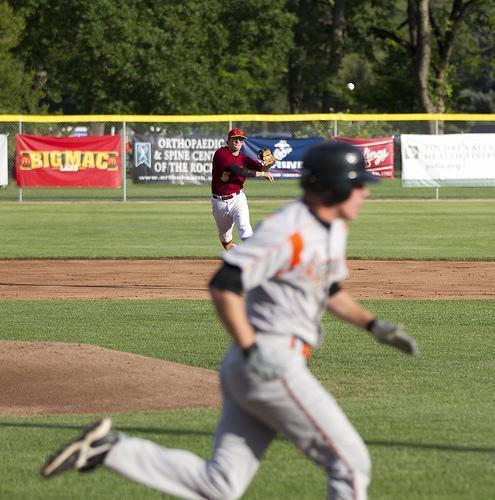How many people are pictured?
Give a very brief answer. 2. 